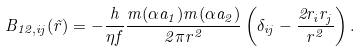<formula> <loc_0><loc_0><loc_500><loc_500>B _ { 1 2 , i j } ( \vec { r } ) = - \frac { h } { \eta f } \frac { m ( \alpha a _ { 1 } ) m ( \alpha a _ { 2 } ) } { 2 \pi r ^ { 2 } } \left ( \delta _ { i j } - \frac { 2 r _ { i } r _ { j } } { r ^ { 2 } } \right ) .</formula> 